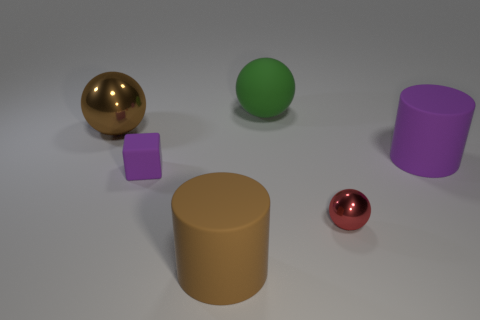Is the number of cylinders to the left of the brown cylinder greater than the number of big objects right of the large purple rubber object?
Offer a very short reply. No. There is a metallic thing on the right side of the object that is to the left of the purple rubber block in front of the big green rubber object; what is its shape?
Your answer should be very brief. Sphere. What shape is the small thing that is left of the big brown object that is in front of the large purple matte object?
Ensure brevity in your answer.  Cube. Is there a big purple cylinder that has the same material as the large green ball?
Keep it short and to the point. Yes. What number of red things are either tiny objects or rubber cylinders?
Your answer should be very brief. 1. Are there any tiny rubber blocks that have the same color as the small metal ball?
Give a very brief answer. No. What size is the cube that is the same material as the large green ball?
Make the answer very short. Small. What number of cubes are either purple things or large green matte things?
Your response must be concise. 1. Is the number of brown metal spheres greater than the number of big matte cylinders?
Your answer should be very brief. No. How many cylinders have the same size as the block?
Give a very brief answer. 0. 